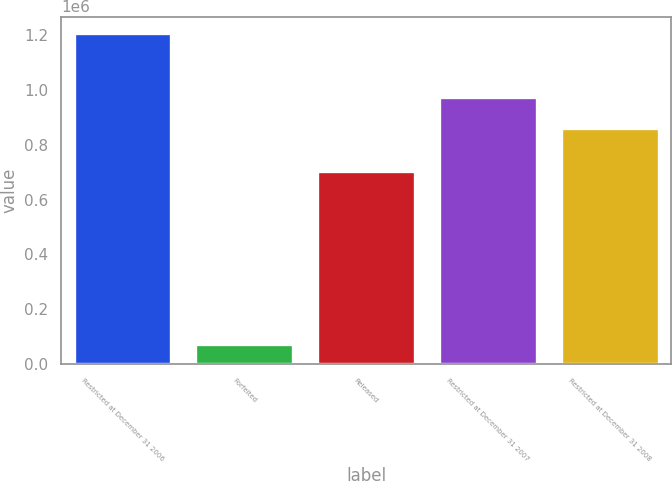Convert chart. <chart><loc_0><loc_0><loc_500><loc_500><bar_chart><fcel>Restricted at December 31 2006<fcel>Forfeited<fcel>Released<fcel>Restricted at December 31 2007<fcel>Restricted at December 31 2008<nl><fcel>1.20835e+06<fcel>73621<fcel>705417<fcel>975992<fcel>862519<nl></chart> 